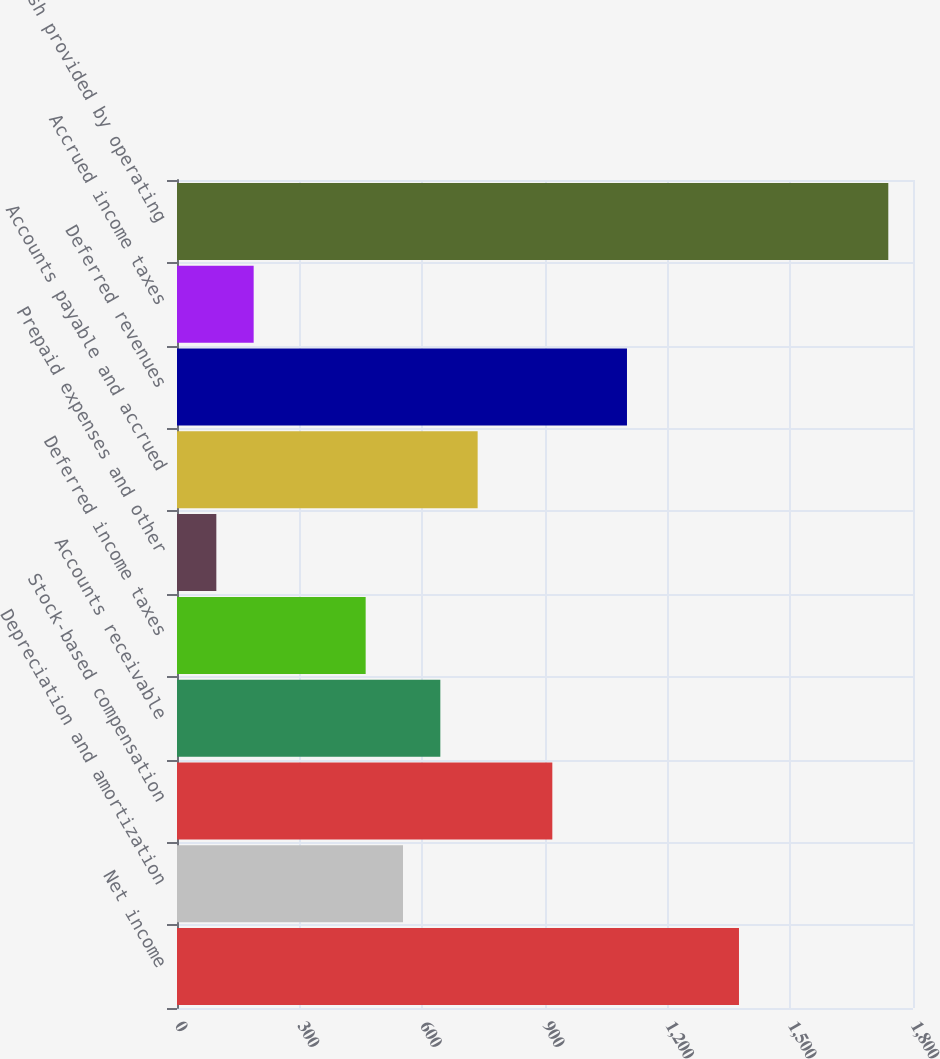<chart> <loc_0><loc_0><loc_500><loc_500><bar_chart><fcel>Net income<fcel>Depreciation and amortization<fcel>Stock-based compensation<fcel>Accounts receivable<fcel>Deferred income taxes<fcel>Prepaid expenses and other<fcel>Accounts payable and accrued<fcel>Deferred revenues<fcel>Accrued income taxes<fcel>Net cash provided by operating<nl><fcel>1374.4<fcel>552.7<fcel>917.9<fcel>644<fcel>461.4<fcel>96.2<fcel>735.3<fcel>1100.5<fcel>187.5<fcel>1739.6<nl></chart> 